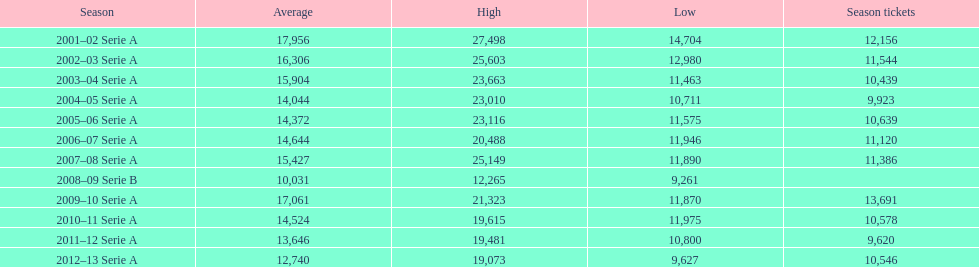In 2001, what was the typical average? 17,956. 